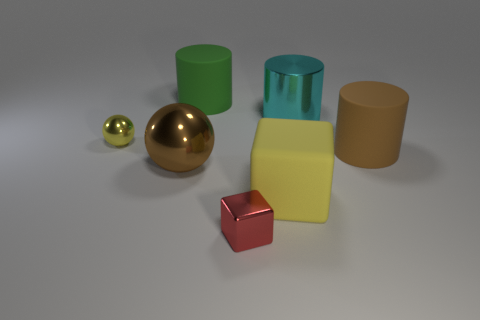Add 1 small yellow objects. How many objects exist? 8 Subtract all balls. How many objects are left? 5 Subtract all blue metal cylinders. Subtract all yellow metal spheres. How many objects are left? 6 Add 3 tiny objects. How many tiny objects are left? 5 Add 7 large brown rubber things. How many large brown rubber things exist? 8 Subtract 0 yellow cylinders. How many objects are left? 7 